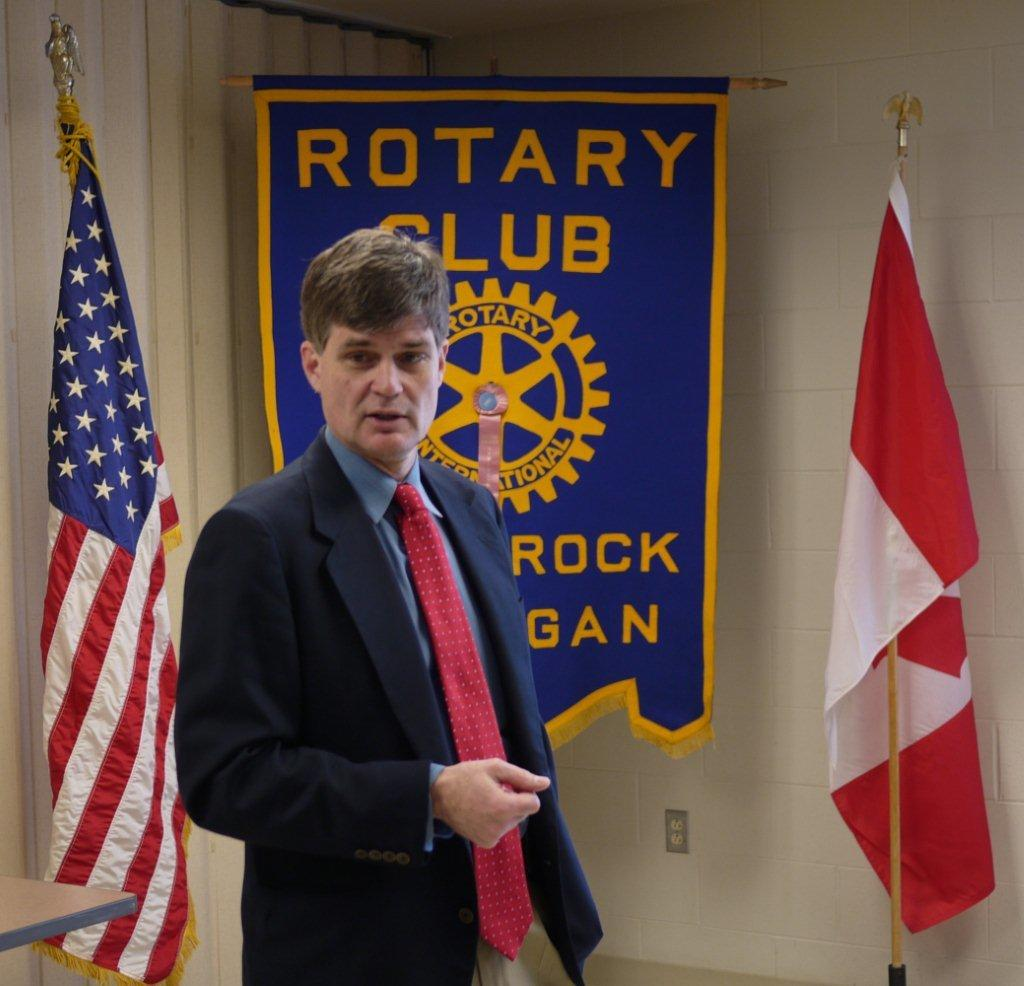Who or what is in the image? There is a person in the image. What is the person wearing? The person is wearing clothes. Where is the person located in the image? The person is in front of a wall. What can be seen in the middle of the image? There is a banner in the middle of the image. How many flags are visible in the image? There are two flags visible in the image, one on the left side and one on the right side. What type of rhythm can be heard coming from the river in the image? There is no river present in the image, so it is not possible to determine what type of rhythm might be heard. 